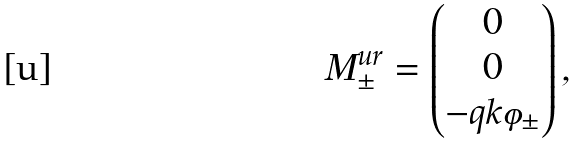Convert formula to latex. <formula><loc_0><loc_0><loc_500><loc_500>M ^ { u r } _ { \pm } = \begin{pmatrix} 0 \\ 0 \\ - q k \varphi _ { \pm } \end{pmatrix} ,</formula> 